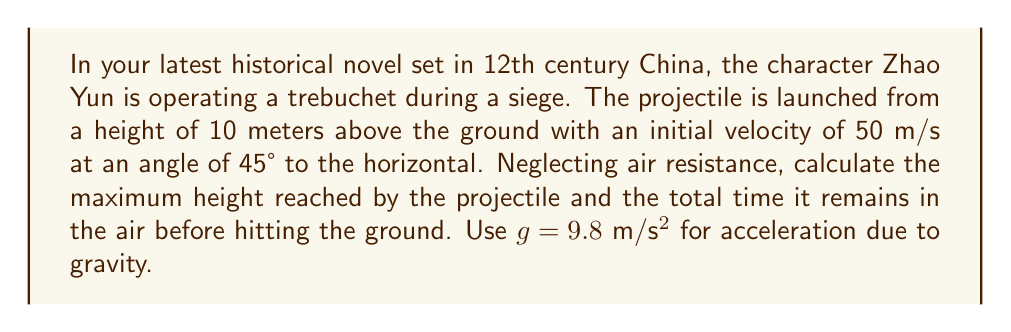Can you answer this question? Let's approach this problem step-by-step:

1. Given information:
   - Initial height (h₀) = 10 m
   - Initial velocity (v₀) = 50 m/s
   - Launch angle (θ) = 45°
   - g = 9.8 m/s²

2. To find the maximum height, we need to consider the vertical component of motion:
   
   Initial vertical velocity: $v_{0y} = v_0 \sin \theta = 50 \sin 45° = 50 \cdot \frac{\sqrt{2}}{2} \approx 35.36$ m/s

3. The time to reach maximum height (t_max) is when vertical velocity becomes zero:
   
   $$v_y = v_{0y} - gt_{max} = 0$$
   $$t_{max} = \frac{v_{0y}}{g} = \frac{35.36}{9.8} \approx 3.61 \text{ s}$$

4. The maximum height reached (h_max) is:
   
   $$h_{max} = h_0 + v_{0y}t_{max} - \frac{1}{2}gt_{max}^2$$
   $$h_{max} = 10 + 35.36 \cdot 3.61 - \frac{1}{2} \cdot 9.8 \cdot 3.61^2$$
   $$h_{max} \approx 73.86 \text{ m}$$

5. For the total time of flight, we need to find when the projectile hits the ground. Using the quadratic formula:
   
   $$0 = h_0 + v_{0y}t - \frac{1}{2}gt^2$$
   $$0 = 10 + 35.36t - 4.9t^2$$
   $$4.9t^2 - 35.36t - 10 = 0$$

   Solving this quadratic equation:
   $$t = \frac{35.36 \pm \sqrt{35.36^2 + 4 \cdot 4.9 \cdot 10}}{2 \cdot 4.9} \approx 7.33 \text{ s}$$

   We take the positive root as the total time of flight.
Answer: Maximum height: 73.86 m; Total time in air: 7.33 s 